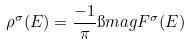<formula> <loc_0><loc_0><loc_500><loc_500>\rho ^ { \sigma } ( E ) = \frac { - 1 } { \pi } \i m a g { F ^ { \sigma } ( E ) }</formula> 